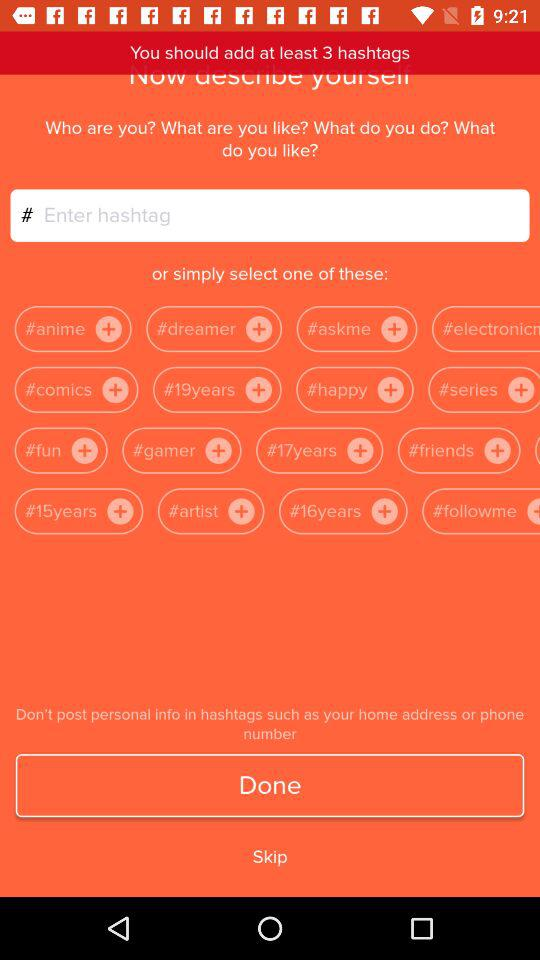How many hashtags are required?
Answer the question using a single word or phrase. At least 3 